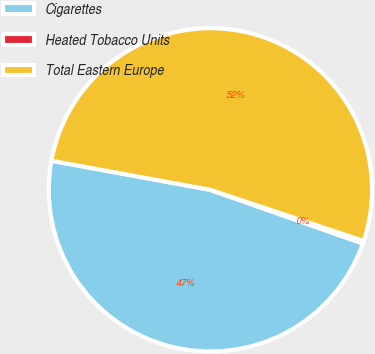<chart> <loc_0><loc_0><loc_500><loc_500><pie_chart><fcel>Cigarettes<fcel>Heated Tobacco Units<fcel>Total Eastern Europe<nl><fcel>47.49%<fcel>0.27%<fcel>52.24%<nl></chart> 